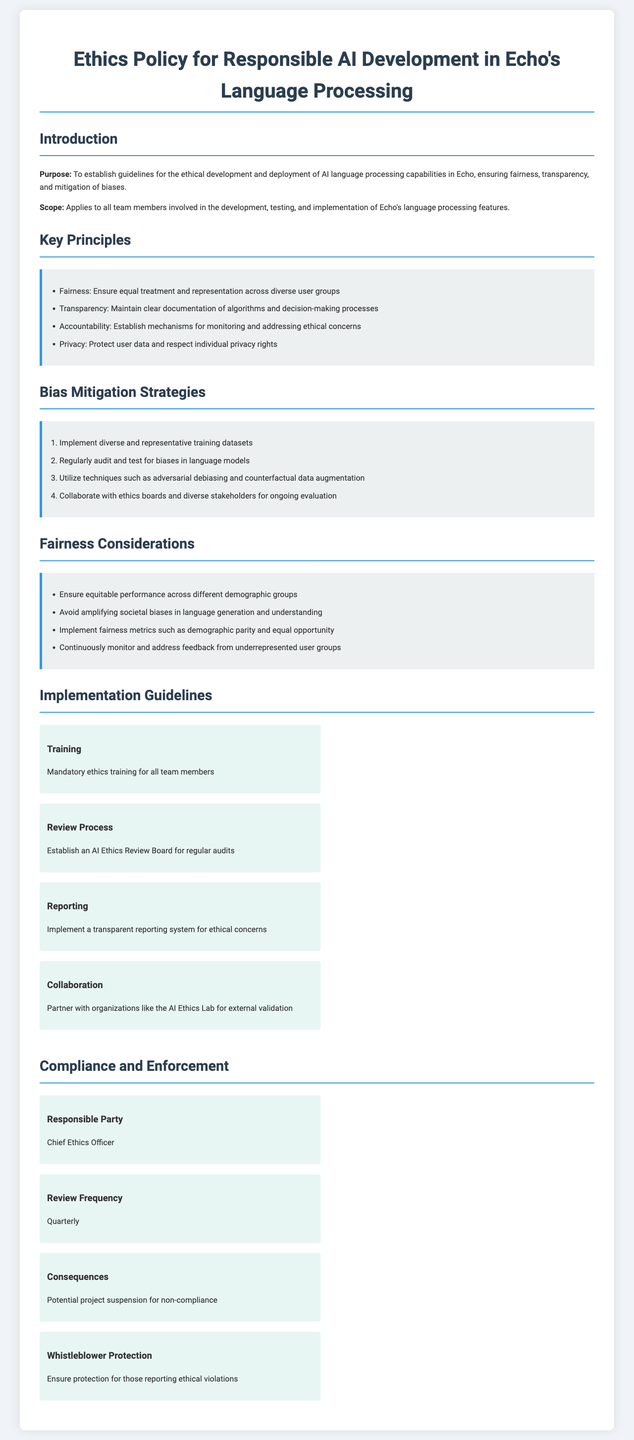What is the purpose of the document? The purpose outlines the main goal of the document, which is to establish guidelines for ethical AI development in Echo.
Answer: To establish guidelines for the ethical development and deployment of AI language processing capabilities in Echo What does the key principle of accountability entail? The accountability key principle requires establishing mechanisms for monitoring and addressing ethical concerns.
Answer: Establish mechanisms for monitoring and addressing ethical concerns How many strategies are listed for bias mitigation? The number of strategies is given as an ordered list in the document.
Answer: Four Who is the responsible party for compliance? The responsible party is explicitly stated in the compliance section of the document.
Answer: Chief Ethics Officer What type of training is mandated for team members? The document specifies the type of training required for all team members involved in AI development.
Answer: Mandatory ethics training How frequently should the compliance review occur? The document specifies a review frequency outlined in the compliance section.
Answer: Quarterly What external organization is mentioned for collaboration? The document references a specific organization to partner with for external validation.
Answer: AI Ethics Lab What metric is suggested to implement for fairness? The document includes specific fairness metrics that should be utilized for evaluation.
Answer: Demographic parity What does the document say about whistleblower protection? The document highlights a specific measure regarding protection for individuals reporting ethical violations.
Answer: Ensure protection for those reporting ethical violations 